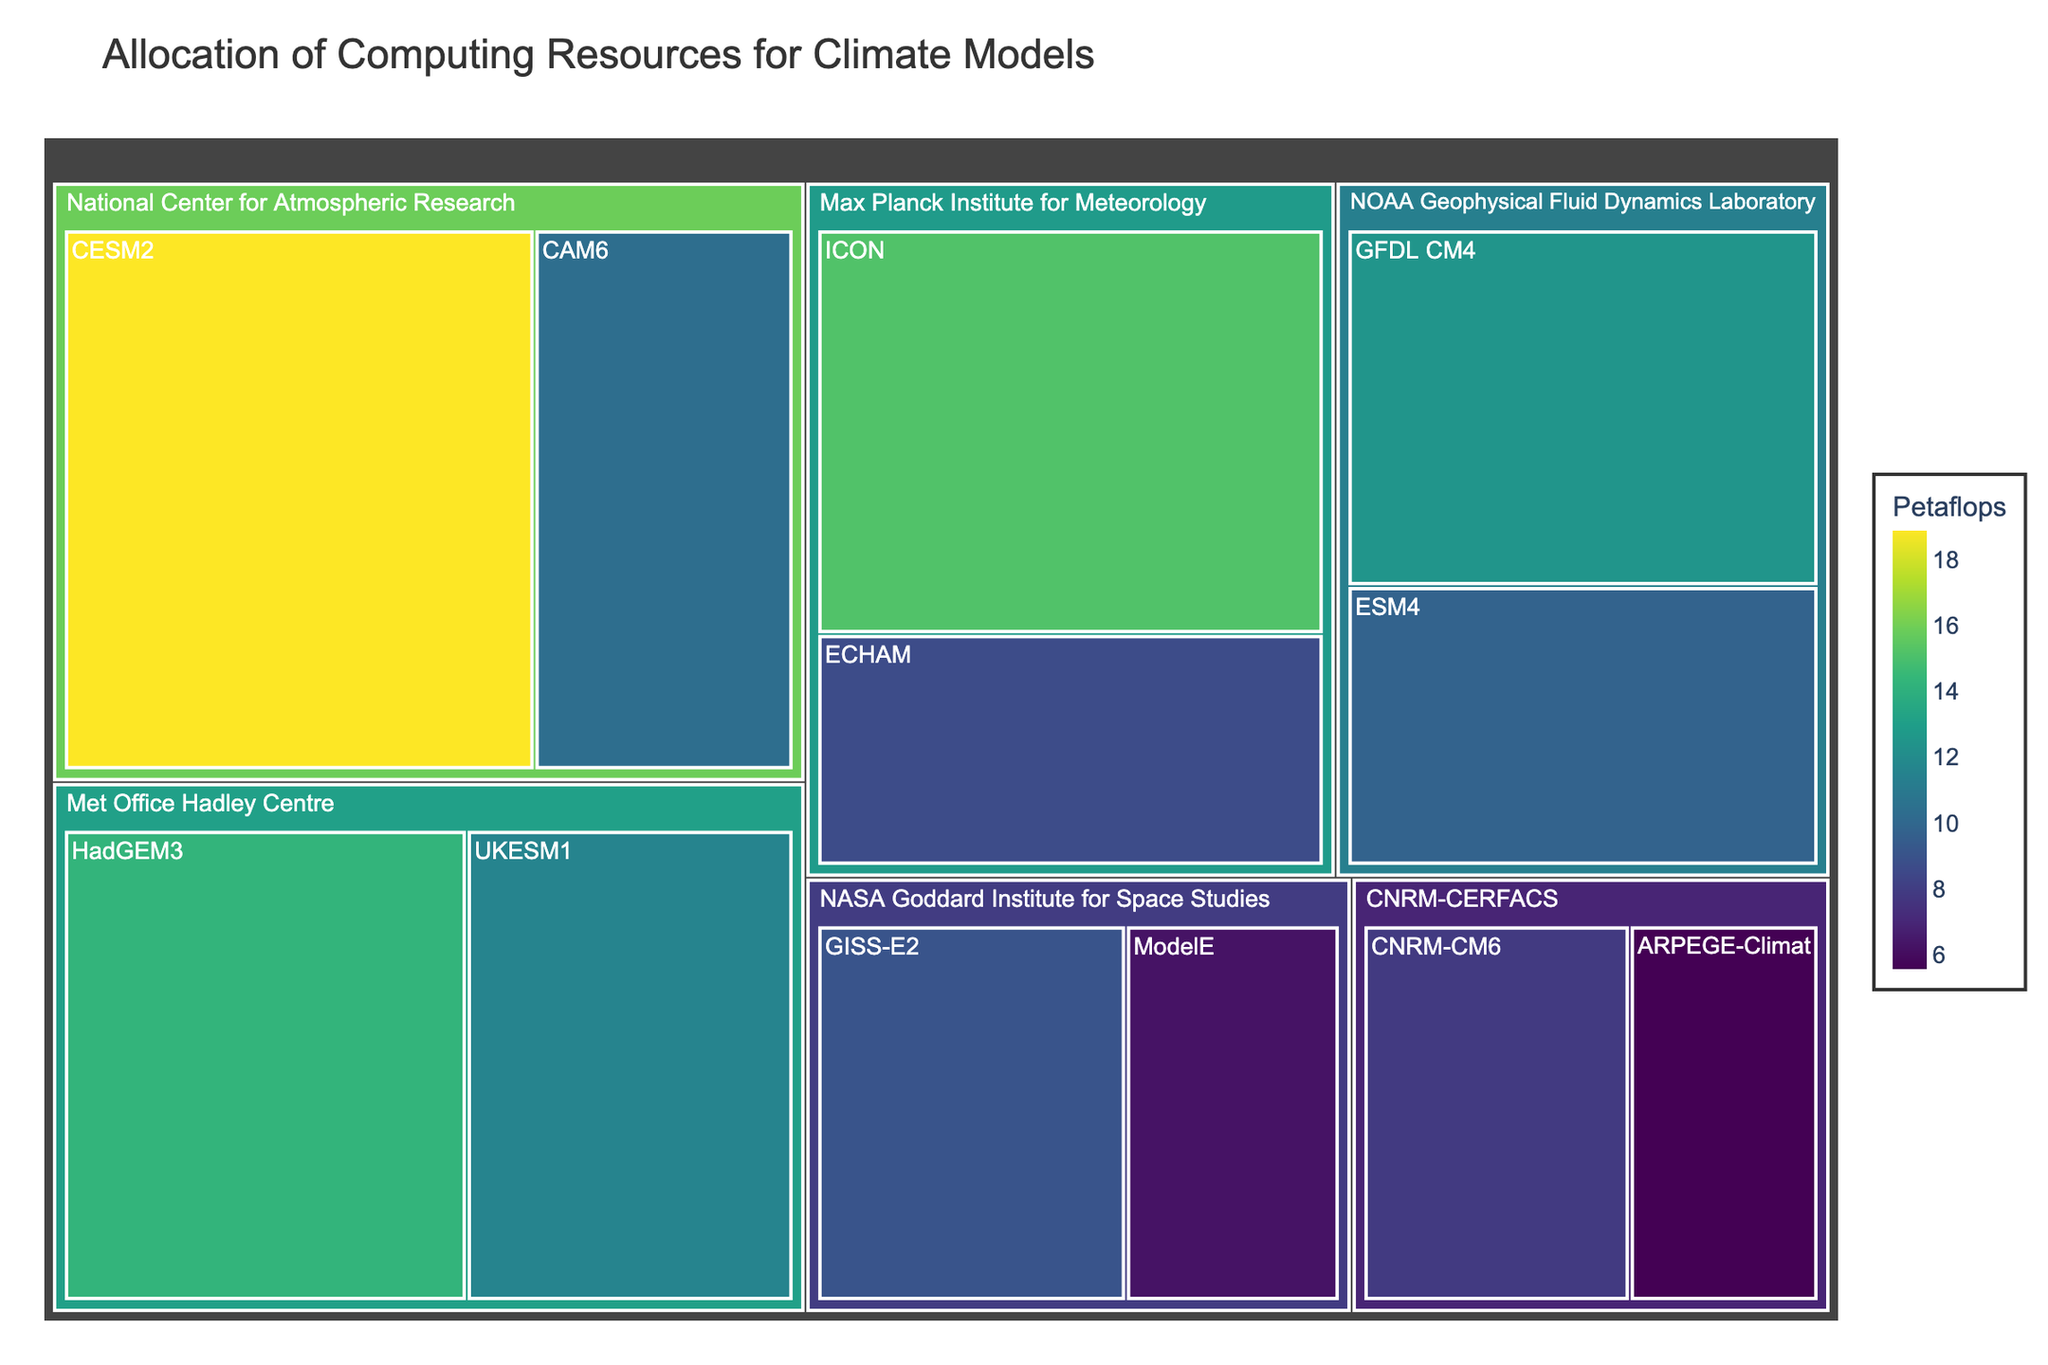How many research centers are represented in the treemap? To find the number of research centers, look at the top level of the treemap, where each distinct segment represents a research center. Count these segments.
Answer: 6 Which research center allocates the most computing resources to a single climate model? Identify the largest segment belonging to a single model type within each research center. Compare these segments to determine which one is the largest.
Answer: National Center for Atmospheric Research (CESM2) What is the total computing resource allocation for the Max Planck Institute for Meteorology? Add the computing resources allocated to the ICON and ECHAM models under the Max Planck Institute for Meteorology. This is 15.2 + 8.7 petaflops.
Answer: 23.9 petaflops Which research center allocates more resources to their respective climate models, NOAA Geophysical Fluid Dynamics Laboratory or Met Office Hadley Centre? Sum the resources for the models under each research center. NOAA Geophysical Fluid Dynamics Laboratory has 12.5 + 9.8, and Met Office Hadley Centre has 14.3 + 11.6. Compare these sums.
Answer: Met Office Hadley Centre Which model type within the NASA Goddard Institute for Space Studies uses fewer computing resources? Look at the two segments representing the model types under the NASA Goddard Institute for Space Studies and compare their values. ModelE has 6.3 petaflops, which is less than 9.1 petaflops for GISS-E2.
Answer: ModelE What's the average computing resource allocation per model type for the CNRM-CERFACS research center? Add the computing resources for the CNRM-CM6 and ARPEGE-Climat models and divide by the number of models. This is (7.9 + 5.6) / 2.
Answer: 6.75 petaflops Which research center distributes their resources more evenly between their model types? Compare the differences in resource allocation between the models for each research center. The center with the smallest difference shows the most even distribution.
Answer: NASA Goddard Institute for Space Studies Which model type uses the highest amount of computing resources overall? Identify the largest single segment in the entire treemap.
Answer: CESM2 How does the resource allocation for the GISS-E2 model compare to the ARPEGE-Climat model? Look at the segments for GISS-E2 and ARPEGE-Climat and compare their values. GISS-E2 has 9.1 petaflops, and ARPEGE-Climat has 5.6 petaflops.
Answer: GISS-E2 has more resources than ARPEGE-Climat What is the combined computing resource allocation of all models under the NOAA Geophysical Fluid Dynamics Laboratory? Sum the computing resources allocated to the GFDL CM4 and ESM4 models. This is 12.5 + 9.8 petaflops.
Answer: 22.3 petaflops 